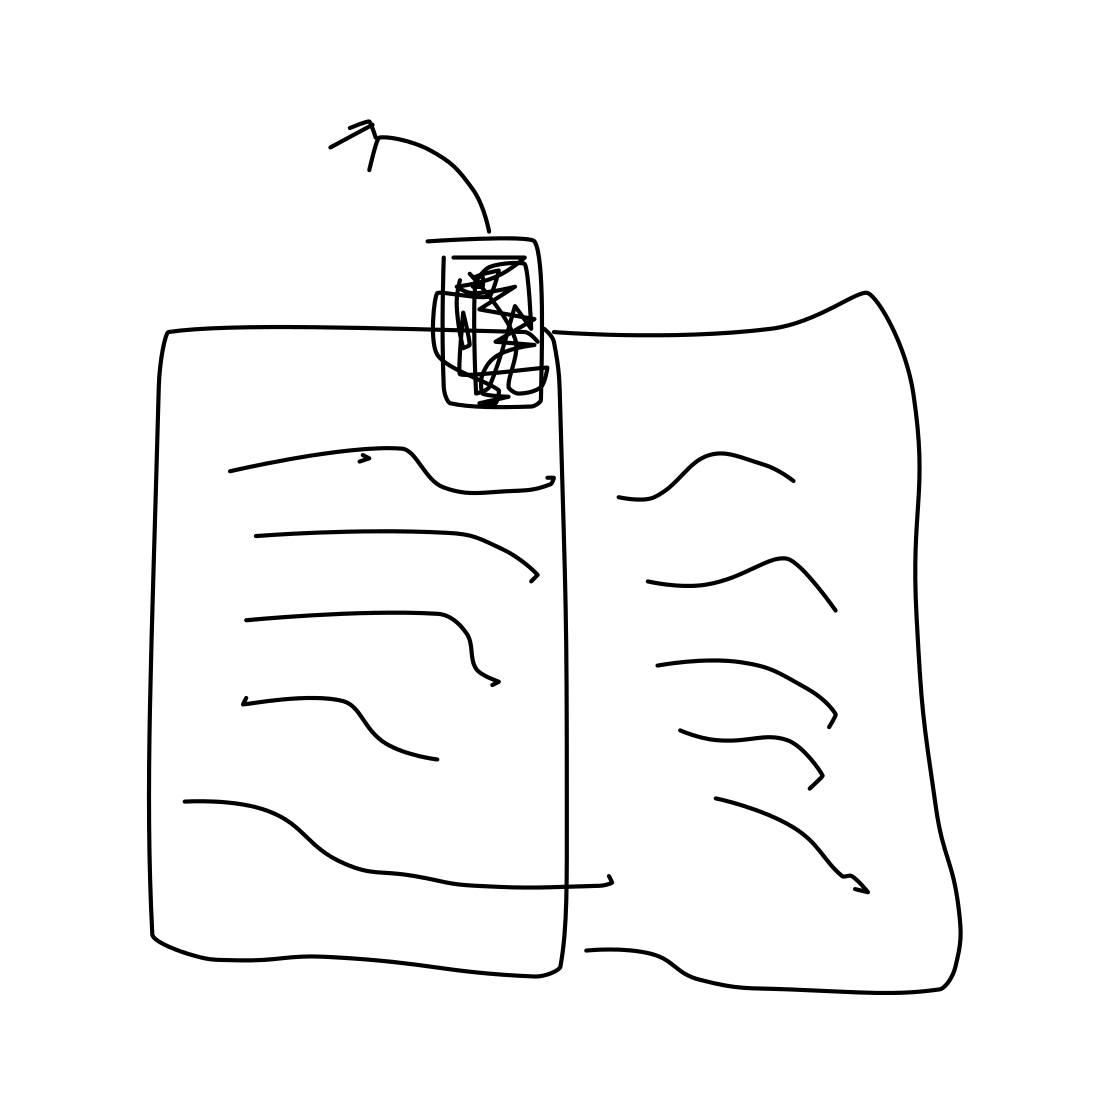What do you think is the setting or context in which this book is placed? The book is laid out flat and appears to be casually left open, suggesting that it might be in a personal, relaxed setting such as a home or a cozy study area where someone has been reading it.  Does the image suggest that the book is frequently used? Yes, the way the book rests open with its pages spread suggests frequent use. The presence of heavy scribbling on the right page may imply regular interaction, possibly for study or note-taking. 